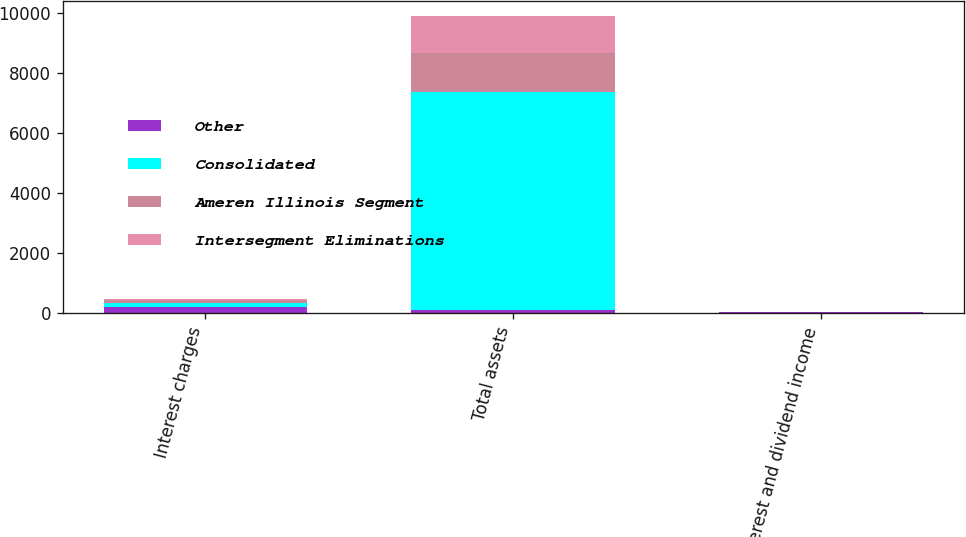Convert chart to OTSL. <chart><loc_0><loc_0><loc_500><loc_500><stacked_bar_chart><ecel><fcel>Interest charges<fcel>Total assets<fcel>Interest and dividend income<nl><fcel>Other<fcel>223<fcel>95<fcel>31<nl><fcel>Consolidated<fcel>129<fcel>7282<fcel>1<nl><fcel>Ameren Illinois Segment<fcel>95<fcel>1300<fcel>1<nl><fcel>Intersegment Eliminations<fcel>38<fcel>1228<fcel>25<nl></chart> 